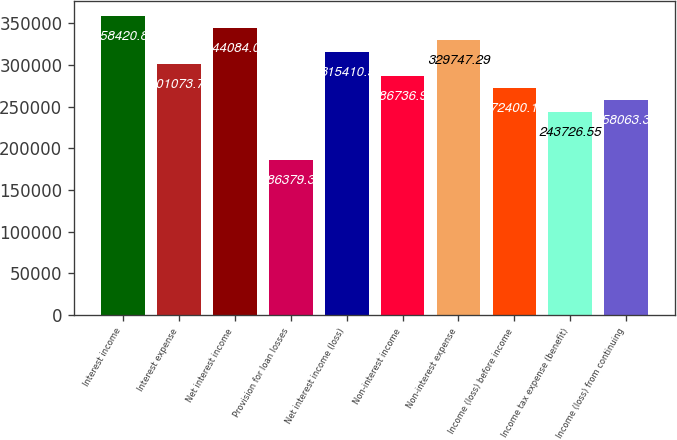Convert chart to OTSL. <chart><loc_0><loc_0><loc_500><loc_500><bar_chart><fcel>Interest income<fcel>Interest expense<fcel>Net interest income<fcel>Provision for loan losses<fcel>Net interest income (loss)<fcel>Non-interest income<fcel>Non-interest expense<fcel>Income (loss) before income<fcel>Income tax expense (benefit)<fcel>Income (loss) from continuing<nl><fcel>358421<fcel>301074<fcel>344084<fcel>186379<fcel>315410<fcel>286737<fcel>329747<fcel>272400<fcel>243727<fcel>258063<nl></chart> 